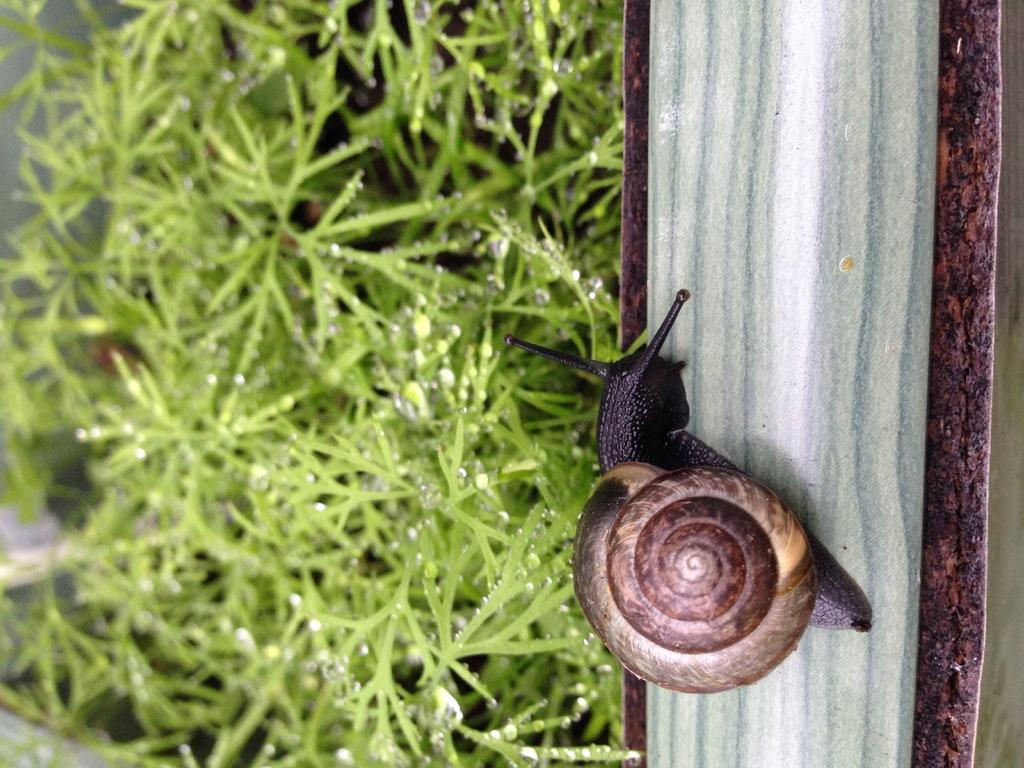What is the main subject in the foreground of the image? There is a snail in the foreground of the image. On which side of the image is the snail located? The snail is on the right side of the image. What type of vegetation is present in the foreground of the image? There is grass in the foreground of the image. On which side of the image is the grass located? The grass is on the left side of the image. What can be observed on the grass in the image? There are water drops on the grass. What type of jelly can be seen on the fork in the image? There is no fork or jelly present in the image. Which direction is the north located in the image? The image does not provide any information about the direction of north. 